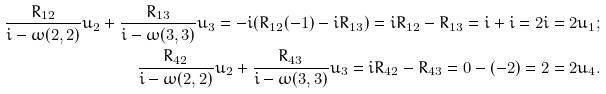<formula> <loc_0><loc_0><loc_500><loc_500>\frac { R _ { 1 2 } } { i - \omega ( 2 , 2 ) } u _ { 2 } + \frac { R _ { 1 3 } } { i - \omega ( 3 , 3 ) } u _ { 3 } = - i ( R _ { 1 2 } ( - 1 ) - i R _ { 1 3 } ) = i R _ { 1 2 } - R _ { 1 3 } = i + i = 2 i = 2 u _ { 1 } ; \\ \frac { R _ { 4 2 } } { i - \omega ( 2 , 2 ) } u _ { 2 } + \frac { R _ { 4 3 } } { i - \omega ( 3 , 3 ) } u _ { 3 } = i R _ { 4 2 } - R _ { 4 3 } = 0 - ( - 2 ) = 2 = 2 u _ { 4 } .</formula> 